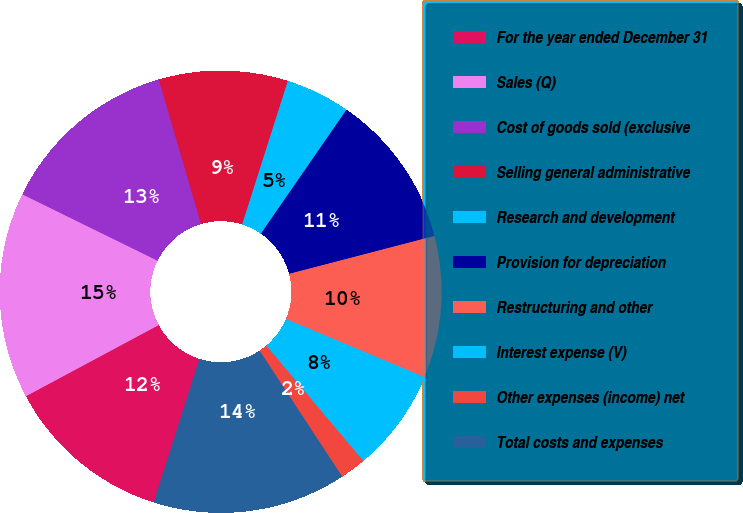Convert chart to OTSL. <chart><loc_0><loc_0><loc_500><loc_500><pie_chart><fcel>For the year ended December 31<fcel>Sales (Q)<fcel>Cost of goods sold (exclusive<fcel>Selling general administrative<fcel>Research and development<fcel>Provision for depreciation<fcel>Restructuring and other<fcel>Interest expense (V)<fcel>Other expenses (income) net<fcel>Total costs and expenses<nl><fcel>12.26%<fcel>15.09%<fcel>13.21%<fcel>9.43%<fcel>4.72%<fcel>11.32%<fcel>10.38%<fcel>7.55%<fcel>1.89%<fcel>14.15%<nl></chart> 